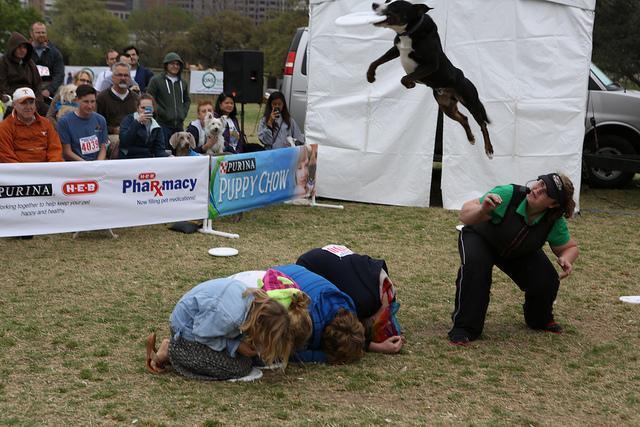How many cars are there?
Give a very brief answer. 2. How many people are there?
Give a very brief answer. 9. How many bottle caps are in the photo?
Give a very brief answer. 0. 